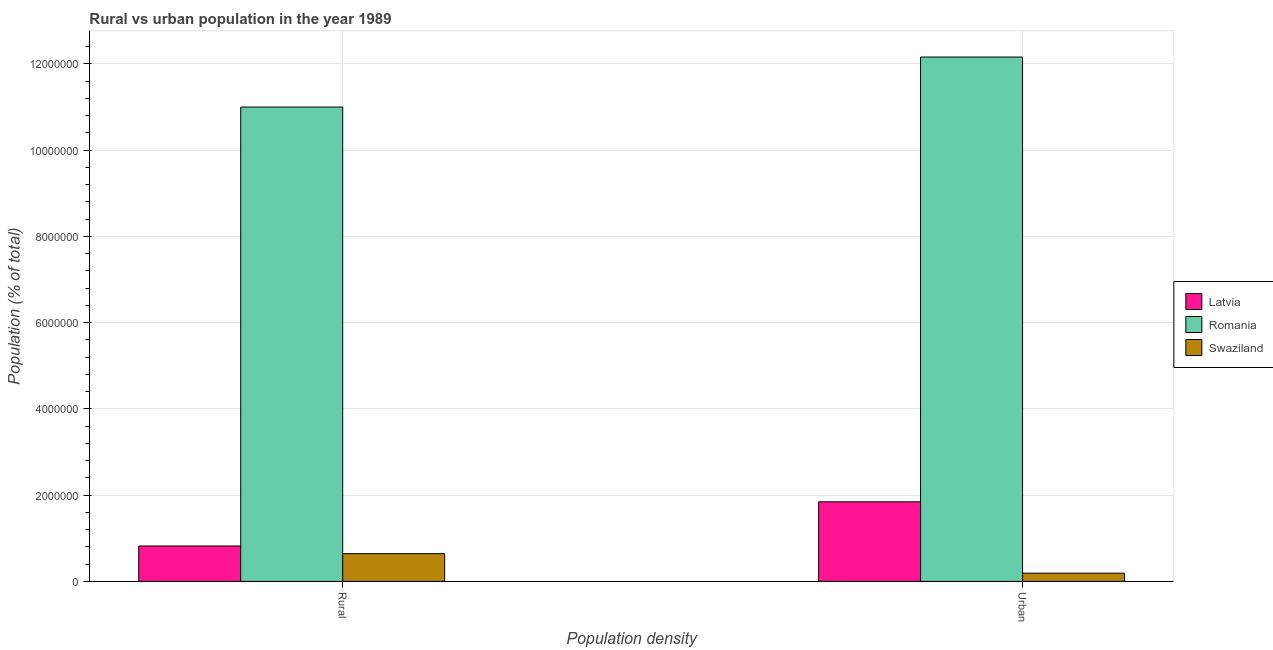Are the number of bars on each tick of the X-axis equal?
Your answer should be very brief. Yes. How many bars are there on the 2nd tick from the left?
Offer a terse response. 3. What is the label of the 1st group of bars from the left?
Give a very brief answer. Rural. What is the urban population density in Romania?
Provide a short and direct response. 1.22e+07. Across all countries, what is the maximum rural population density?
Your response must be concise. 1.10e+07. Across all countries, what is the minimum urban population density?
Ensure brevity in your answer.  1.91e+05. In which country was the urban population density maximum?
Your answer should be compact. Romania. In which country was the rural population density minimum?
Give a very brief answer. Swaziland. What is the total urban population density in the graph?
Make the answer very short. 1.42e+07. What is the difference between the rural population density in Latvia and that in Romania?
Ensure brevity in your answer.  -1.02e+07. What is the difference between the rural population density in Romania and the urban population density in Swaziland?
Keep it short and to the point. 1.08e+07. What is the average rural population density per country?
Provide a short and direct response. 4.16e+06. What is the difference between the urban population density and rural population density in Romania?
Make the answer very short. 1.16e+06. What is the ratio of the urban population density in Swaziland to that in Romania?
Your answer should be compact. 0.02. Is the urban population density in Romania less than that in Latvia?
Provide a short and direct response. No. What does the 1st bar from the left in Urban represents?
Offer a very short reply. Latvia. What does the 2nd bar from the right in Urban represents?
Your response must be concise. Romania. How many bars are there?
Your response must be concise. 6. Does the graph contain any zero values?
Your response must be concise. No. Does the graph contain grids?
Keep it short and to the point. Yes. How many legend labels are there?
Keep it short and to the point. 3. How are the legend labels stacked?
Your answer should be very brief. Vertical. What is the title of the graph?
Provide a succinct answer. Rural vs urban population in the year 1989. What is the label or title of the X-axis?
Offer a very short reply. Population density. What is the label or title of the Y-axis?
Your response must be concise. Population (% of total). What is the Population (% of total) of Latvia in Rural?
Your response must be concise. 8.21e+05. What is the Population (% of total) in Romania in Rural?
Keep it short and to the point. 1.10e+07. What is the Population (% of total) of Swaziland in Rural?
Offer a terse response. 6.43e+05. What is the Population (% of total) of Latvia in Urban?
Offer a terse response. 1.85e+06. What is the Population (% of total) in Romania in Urban?
Make the answer very short. 1.22e+07. What is the Population (% of total) in Swaziland in Urban?
Keep it short and to the point. 1.91e+05. Across all Population density, what is the maximum Population (% of total) of Latvia?
Keep it short and to the point. 1.85e+06. Across all Population density, what is the maximum Population (% of total) in Romania?
Provide a succinct answer. 1.22e+07. Across all Population density, what is the maximum Population (% of total) in Swaziland?
Make the answer very short. 6.43e+05. Across all Population density, what is the minimum Population (% of total) of Latvia?
Give a very brief answer. 8.21e+05. Across all Population density, what is the minimum Population (% of total) of Romania?
Make the answer very short. 1.10e+07. Across all Population density, what is the minimum Population (% of total) in Swaziland?
Your response must be concise. 1.91e+05. What is the total Population (% of total) of Latvia in the graph?
Offer a very short reply. 2.67e+06. What is the total Population (% of total) of Romania in the graph?
Provide a short and direct response. 2.32e+07. What is the total Population (% of total) of Swaziland in the graph?
Ensure brevity in your answer.  8.34e+05. What is the difference between the Population (% of total) of Latvia in Rural and that in Urban?
Provide a short and direct response. -1.02e+06. What is the difference between the Population (% of total) of Romania in Rural and that in Urban?
Offer a very short reply. -1.16e+06. What is the difference between the Population (% of total) in Swaziland in Rural and that in Urban?
Offer a terse response. 4.52e+05. What is the difference between the Population (% of total) of Latvia in Rural and the Population (% of total) of Romania in Urban?
Your response must be concise. -1.13e+07. What is the difference between the Population (% of total) of Latvia in Rural and the Population (% of total) of Swaziland in Urban?
Provide a short and direct response. 6.31e+05. What is the difference between the Population (% of total) of Romania in Rural and the Population (% of total) of Swaziland in Urban?
Offer a very short reply. 1.08e+07. What is the average Population (% of total) in Latvia per Population density?
Your answer should be very brief. 1.33e+06. What is the average Population (% of total) of Romania per Population density?
Give a very brief answer. 1.16e+07. What is the average Population (% of total) in Swaziland per Population density?
Your response must be concise. 4.17e+05. What is the difference between the Population (% of total) in Latvia and Population (% of total) in Romania in Rural?
Ensure brevity in your answer.  -1.02e+07. What is the difference between the Population (% of total) of Latvia and Population (% of total) of Swaziland in Rural?
Offer a terse response. 1.78e+05. What is the difference between the Population (% of total) in Romania and Population (% of total) in Swaziland in Rural?
Make the answer very short. 1.04e+07. What is the difference between the Population (% of total) of Latvia and Population (% of total) of Romania in Urban?
Your response must be concise. -1.03e+07. What is the difference between the Population (% of total) of Latvia and Population (% of total) of Swaziland in Urban?
Your answer should be compact. 1.65e+06. What is the difference between the Population (% of total) in Romania and Population (% of total) in Swaziland in Urban?
Offer a very short reply. 1.20e+07. What is the ratio of the Population (% of total) of Latvia in Rural to that in Urban?
Your answer should be very brief. 0.45. What is the ratio of the Population (% of total) of Romania in Rural to that in Urban?
Provide a short and direct response. 0.9. What is the ratio of the Population (% of total) in Swaziland in Rural to that in Urban?
Provide a succinct answer. 3.37. What is the difference between the highest and the second highest Population (% of total) in Latvia?
Provide a succinct answer. 1.02e+06. What is the difference between the highest and the second highest Population (% of total) in Romania?
Keep it short and to the point. 1.16e+06. What is the difference between the highest and the second highest Population (% of total) in Swaziland?
Give a very brief answer. 4.52e+05. What is the difference between the highest and the lowest Population (% of total) in Latvia?
Provide a short and direct response. 1.02e+06. What is the difference between the highest and the lowest Population (% of total) of Romania?
Keep it short and to the point. 1.16e+06. What is the difference between the highest and the lowest Population (% of total) in Swaziland?
Your answer should be compact. 4.52e+05. 